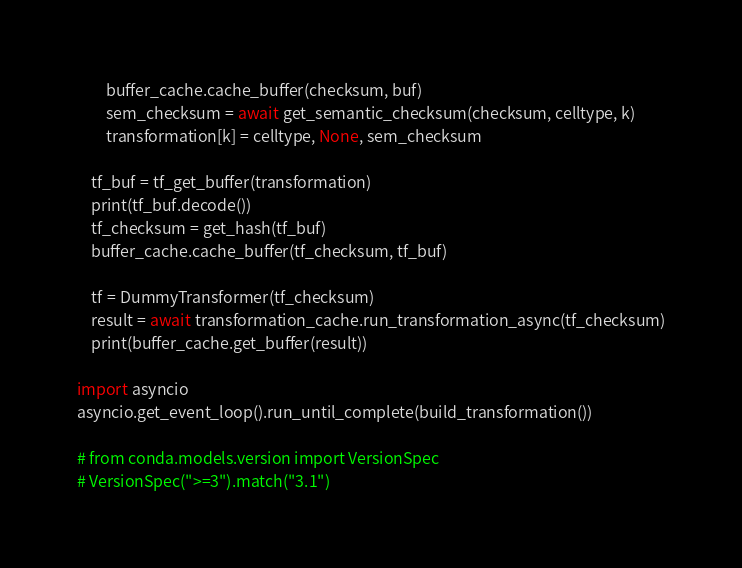<code> <loc_0><loc_0><loc_500><loc_500><_Python_>        buffer_cache.cache_buffer(checksum, buf)
        sem_checksum = await get_semantic_checksum(checksum, celltype, k)
        transformation[k] = celltype, None, sem_checksum

    tf_buf = tf_get_buffer(transformation)
    print(tf_buf.decode())
    tf_checksum = get_hash(tf_buf)
    buffer_cache.cache_buffer(tf_checksum, tf_buf)
    
    tf = DummyTransformer(tf_checksum)
    result = await transformation_cache.run_transformation_async(tf_checksum)
    print(buffer_cache.get_buffer(result))

import asyncio
asyncio.get_event_loop().run_until_complete(build_transformation())

# from conda.models.version import VersionSpec
# VersionSpec(">=3").match("3.1")
</code> 